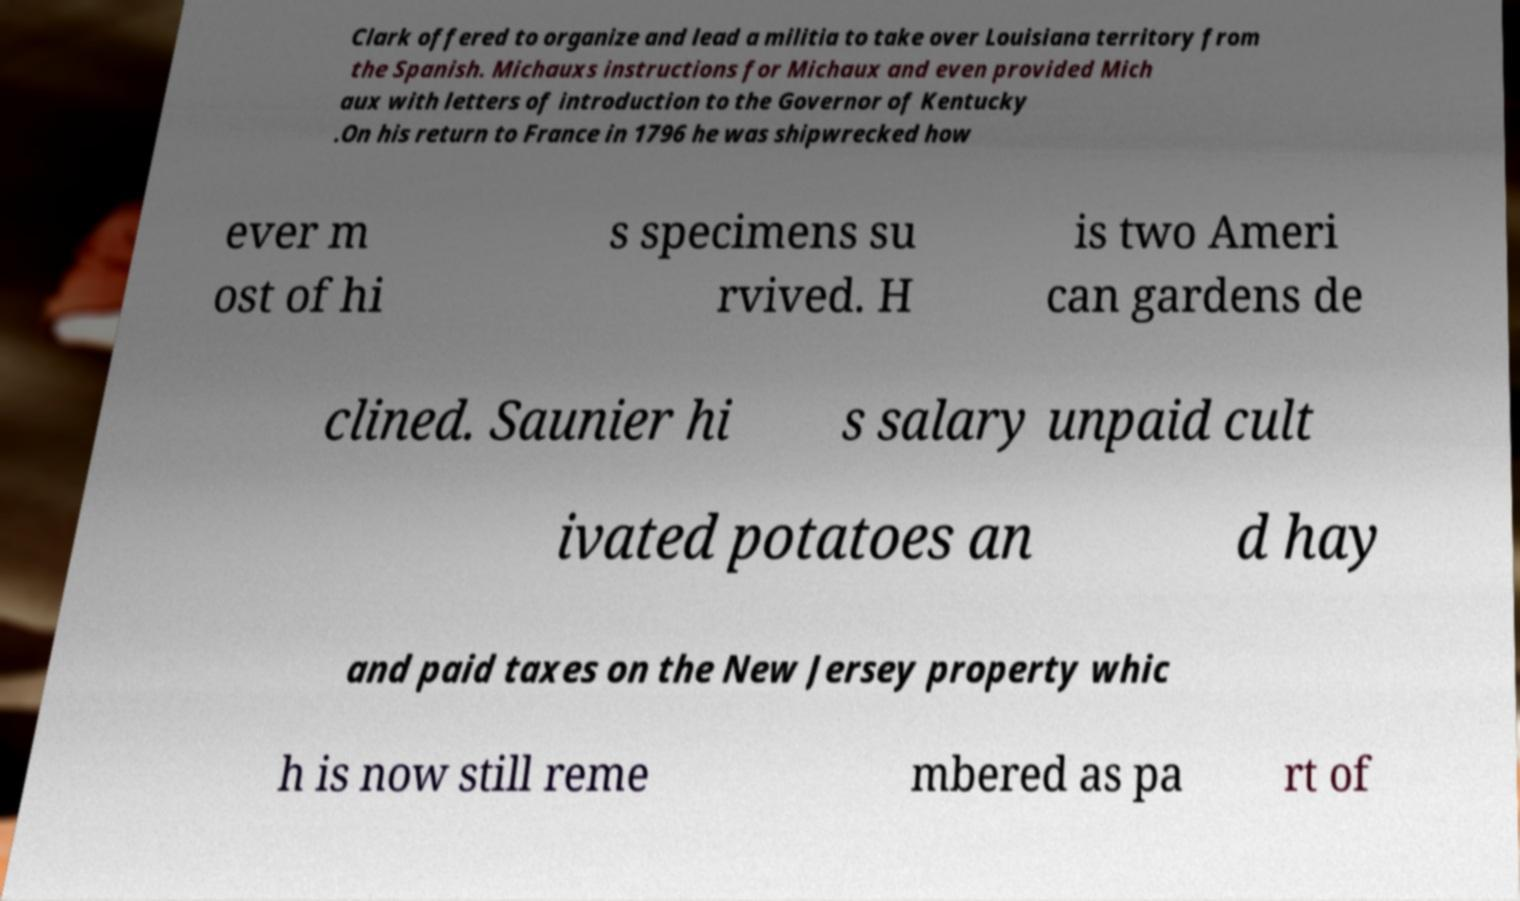I need the written content from this picture converted into text. Can you do that? Clark offered to organize and lead a militia to take over Louisiana territory from the Spanish. Michauxs instructions for Michaux and even provided Mich aux with letters of introduction to the Governor of Kentucky .On his return to France in 1796 he was shipwrecked how ever m ost of hi s specimens su rvived. H is two Ameri can gardens de clined. Saunier hi s salary unpaid cult ivated potatoes an d hay and paid taxes on the New Jersey property whic h is now still reme mbered as pa rt of 